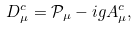<formula> <loc_0><loc_0><loc_500><loc_500>D ^ { c } _ { \mu } = \mathcal { P } _ { \mu } - i g A ^ { c } _ { \mu } ,</formula> 